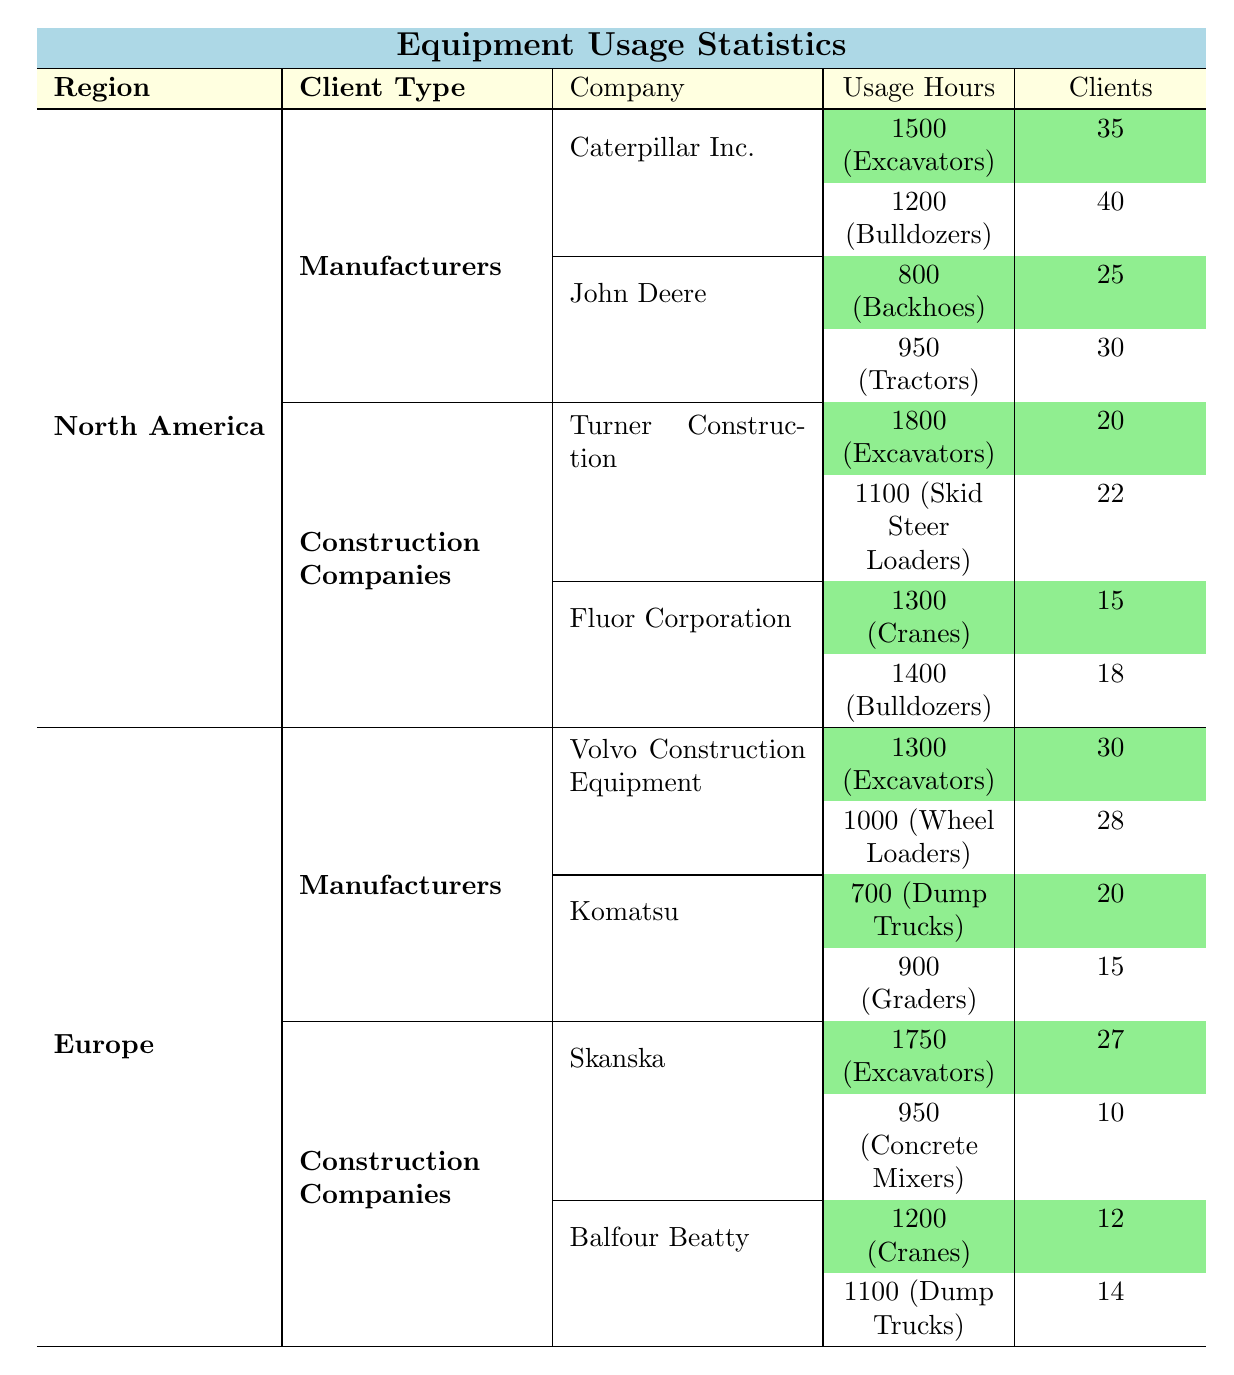What is the total usage hours of Excavators by Manufacturers in North America? The total usage hours for Excavators by Manufacturers in North America are 1500 hours (Caterpillar Inc.) plus 0 hours (John Deere has no Excavators listed), which equals 1500 hours.
Answer: 1500 Which Construction Company in Europe has the highest usage hours for Excavators? Skanska has the highest usage hours for Excavators in Europe, with 1750 hours compared to Volvo Construction Equipment (1300 hours), which is lower.
Answer: Skanska Does Caterpillar Inc. have more Clients than John Deere in North America? Caterpillar Inc. has 35 clients for Excavators and 40 for Bulldozers, totaling 75 clients. John Deere has 25 clients for Backhoes and 30 for Tractors, totaling 55 clients. Since 75 > 55, the statement is true.
Answer: Yes What is the average usage hours for Construction Companies in North America? The total usage hours for Construction Companies in North America are 1800 (Turner Construction, Excavators) + 1100 (Turner Construction, Skid Steer Loaders) + 1300 (Fluor Corporation, Cranes) + 1400 (Fluor Corporation, Bulldozers) = 4600. There are 4 data points, so the average is 4600 / 4 = 1150.
Answer: 1150 Are there more clients using Excavators in North America or Europe? In North America, there are 35 (Caterpillar) + 20 (Turner Construction) = 55 clients for Excavators. In Europe, there are 30 (Volvo Construction Equipment) + 27 (Skanska) = 57 clients for Excavators. Since 55 < 57, the statement is false.
Answer: No 